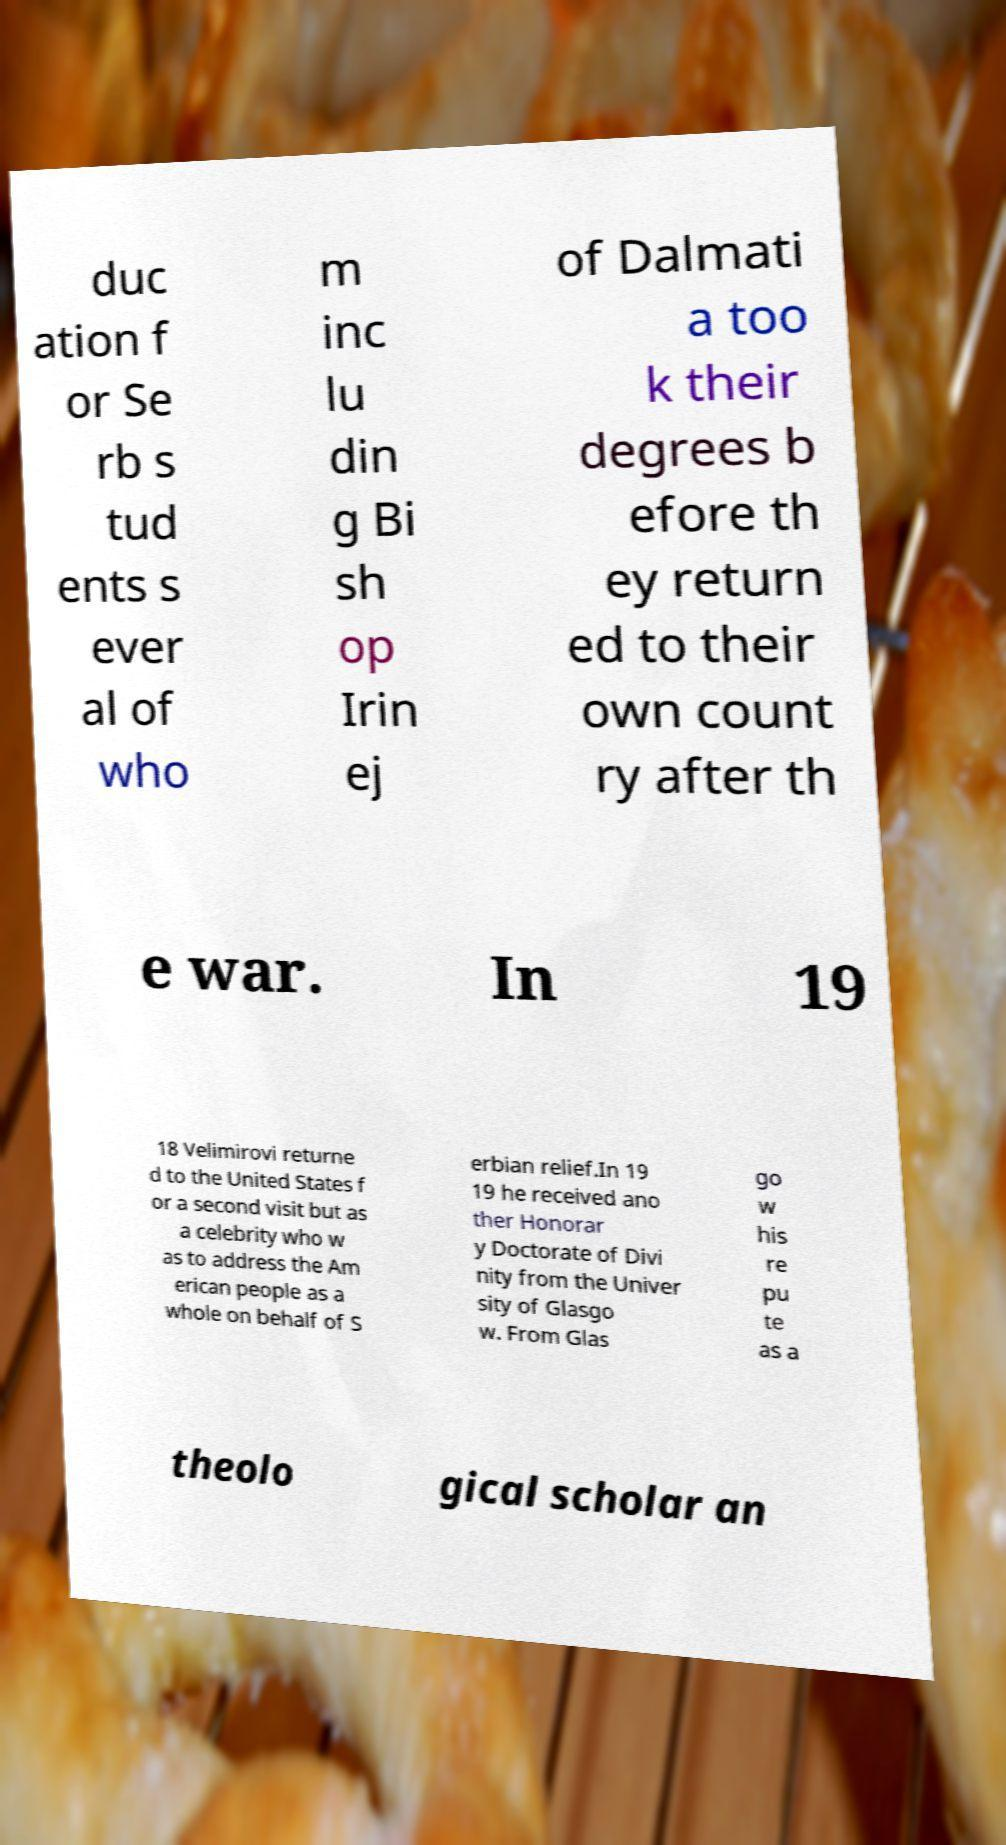There's text embedded in this image that I need extracted. Can you transcribe it verbatim? duc ation f or Se rb s tud ents s ever al of who m inc lu din g Bi sh op Irin ej of Dalmati a too k their degrees b efore th ey return ed to their own count ry after th e war. In 19 18 Velimirovi returne d to the United States f or a second visit but as a celebrity who w as to address the Am erican people as a whole on behalf of S erbian relief.In 19 19 he received ano ther Honorar y Doctorate of Divi nity from the Univer sity of Glasgo w. From Glas go w his re pu te as a theolo gical scholar an 